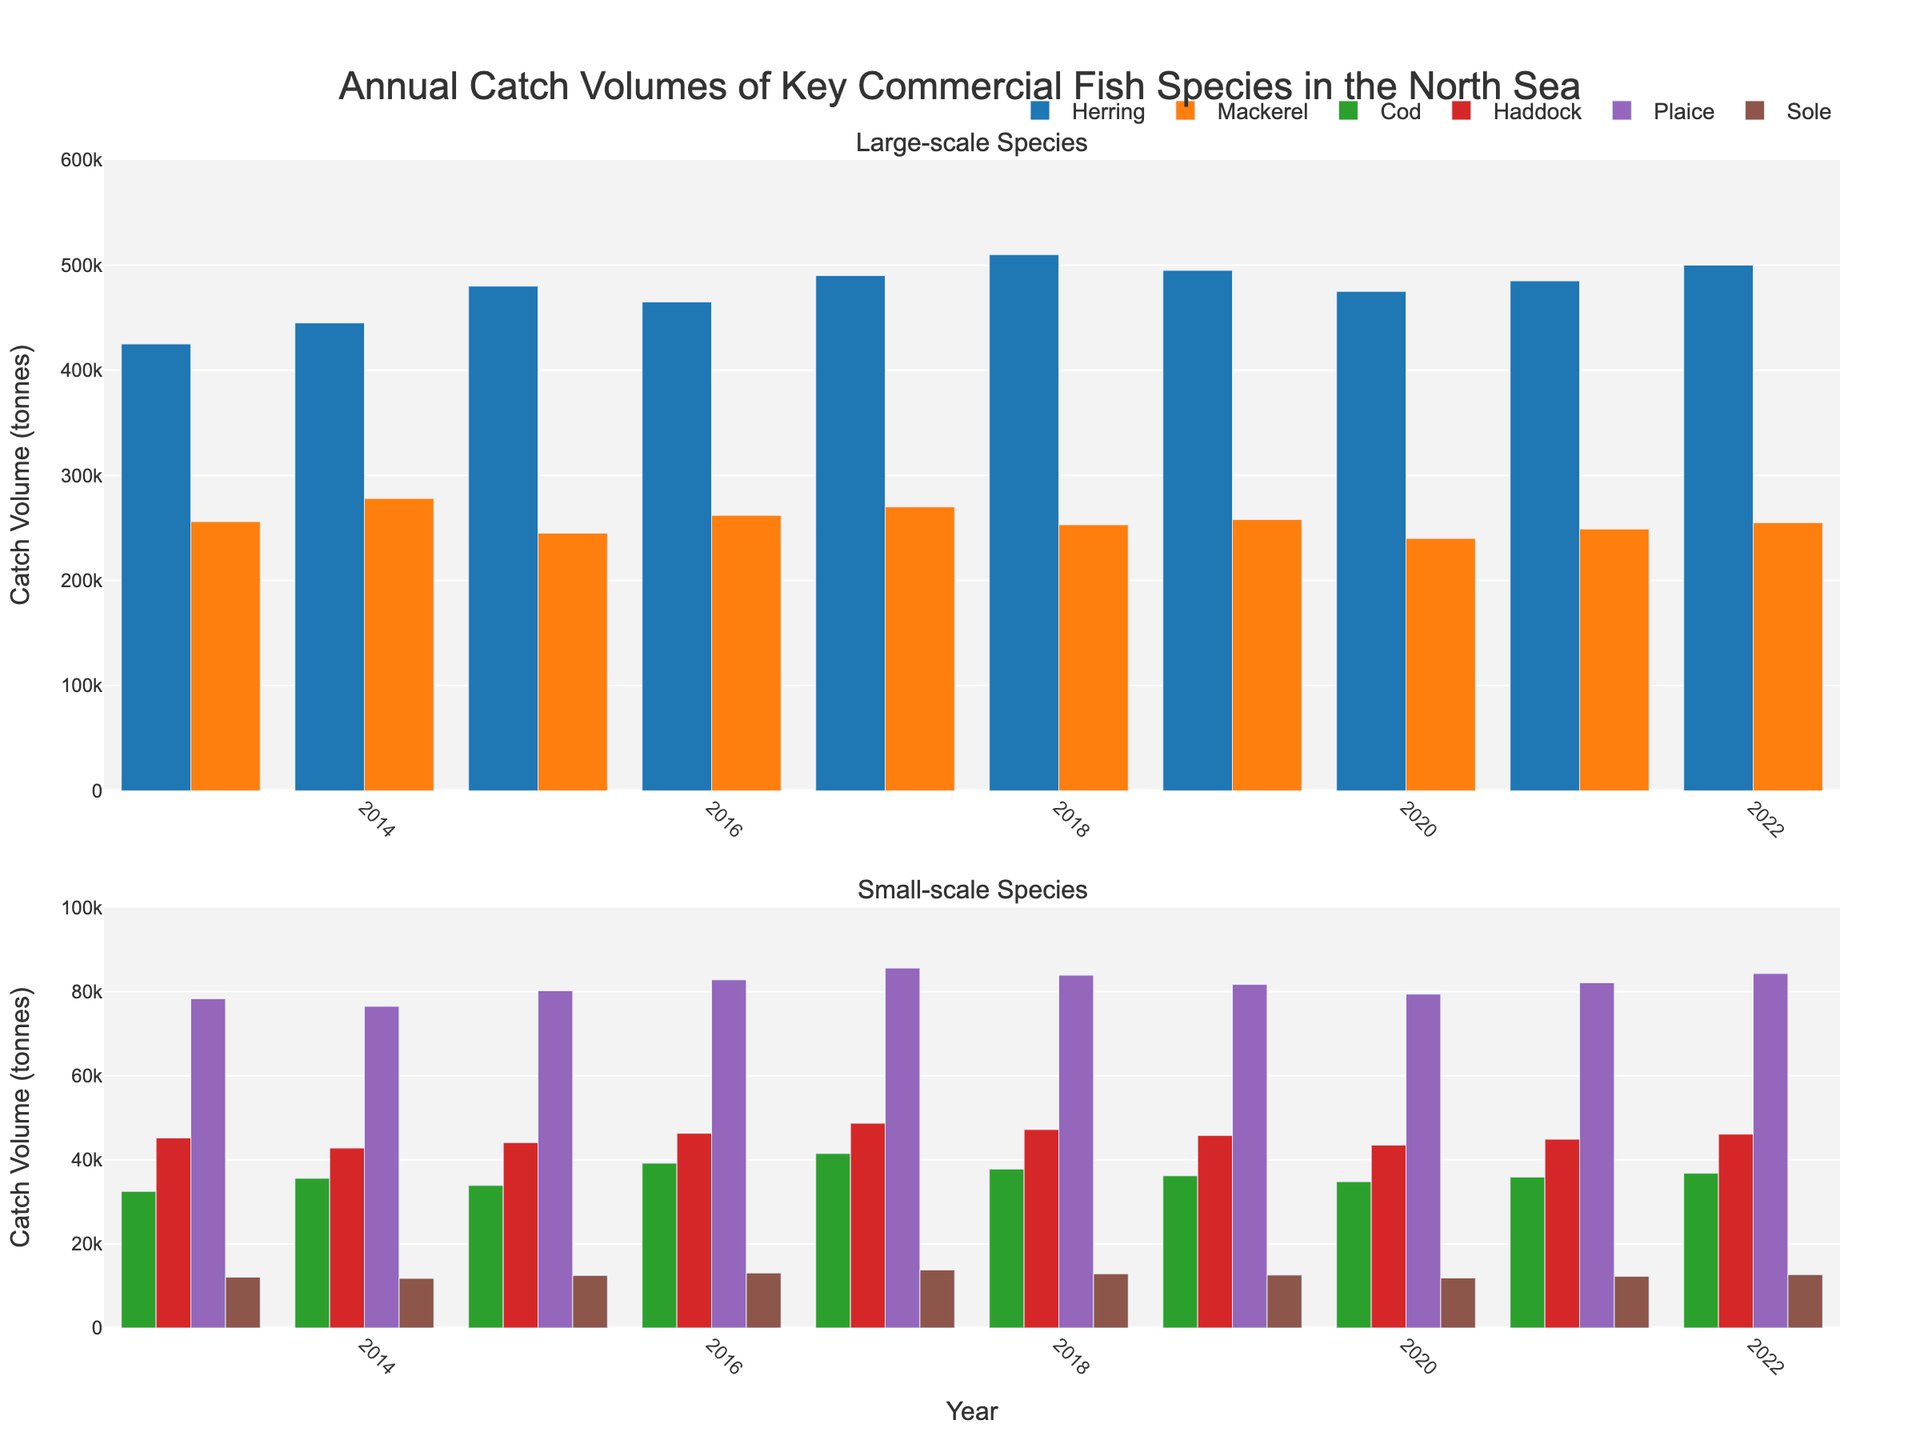What's the catch volume of Herring in 2018? Observe the height of the Herring bar in the top subplot corresponding to the year 2018. It measures 510,000 tonnes.
Answer: 510,000 tonnes In which year did Mackerel have the smallest catch volume? Compare the heights of the Mackerel bars in the top subplot for all years. The shortest bar is in the year 2020, representing 240,000 tonnes.
Answer: 2020 How did the catch volume of Cod change from 2013 to 2016? Note the height of the Cod bars for 2013 and 2016 in the bottom subplot. In 2013, it's 32,500 tonnes, and in 2016, it's 39,200 tonnes. The volume increased by 6,700 tonnes.
Answer: Increased by 6,700 tonnes What was the combined catch volume of Haddock and Sole in 2021? Find the bars for Haddock and Sole in 2021 in the bottom subplot. Haddock is 44,900 tonnes and Sole is 12,300 tonnes. Add these values: 44,900 + 12,300 = 57,200 tonnes.
Answer: 57,200 tonnes Which species had the most stable catch volume over the decade? Observe the variability in bar heights for each species in both subplots over the years. Plaice exhibits relatively minor fluctuations.
Answer: Plaice When did Mackerel and Herring both have their highest catch volumes? Identify the year where the heights of both Mackerel and Herring bars in the top subplot are the tallest. Both are highest in 2022.
Answer: 2022 By how much did the catch volume of Plaice change from 2017 to 2022? Observe the height of the Plaice bars for 2017 and 2022 in the bottom subplot. In 2017, it's 85,600 tonnes; in 2022, it's 84,300 tonnes. The difference is 85,600 - 84,300 = 1,300 tonnes.
Answer: Decreased by 1,300 tonnes What is the visual distinction for the species with the highest catch volume in 2022? The species with the highest catch volume in 2022 is Herring. Its bar is significantly taller and is colored blue, making it visually distinct.
Answer: Blue bar, tallest Between Cod and Haddock, which species had a higher catch volume in 2015 and by how much? Compare the heights of the Cod and Haddock bars in 2015 in the bottom subplot. Cod is 33,900 tonnes and Haddock is 44,100 tonnes. Haddock is higher by 44,100 - 33,900 = 10,200 tonnes.
Answer: Haddock by 10,200 tonnes What’s the average catch volume of Sole from 2019 to 2022? Find the Sole bars for 2019-2022 in the bottom subplot. The values are 12,600, 11,900, 12,300, and 12,700 tonnes. Average: (12,600 + 11,900 + 12,300 + 12,700) / 4 = 12,375 tonnes.
Answer: 12,375 tonnes 